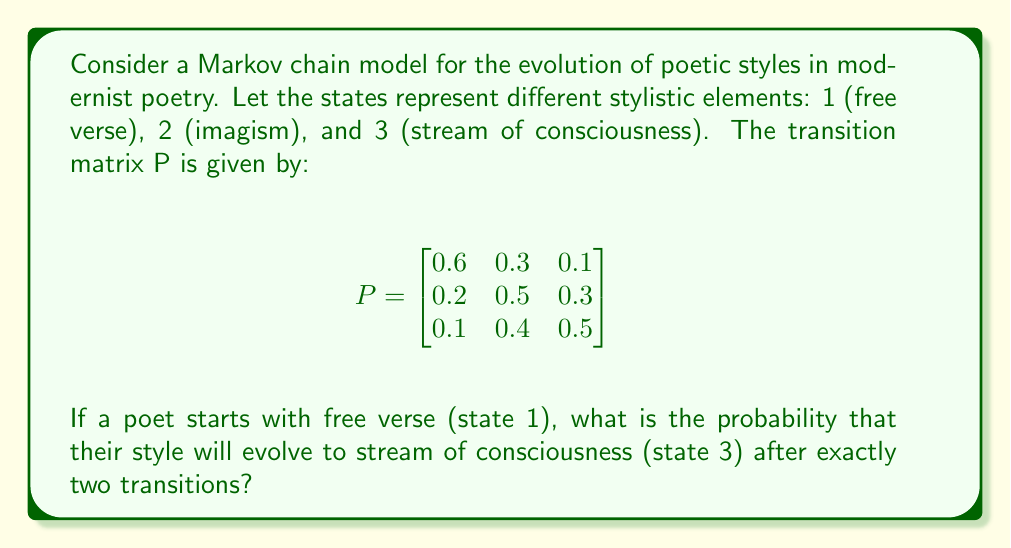Teach me how to tackle this problem. To solve this problem, we need to use the Chapman-Kolmogorov equations for Markov chains. We want to find the probability of going from state 1 to state 3 in exactly two steps.

Step 1: Calculate $P^2$ (the transition matrix for two steps)
$$P^2 = P \times P = \begin{bmatrix}
0.6 & 0.3 & 0.1 \\
0.2 & 0.5 & 0.3 \\
0.1 & 0.4 & 0.5
\end{bmatrix} \times \begin{bmatrix}
0.6 & 0.3 & 0.1 \\
0.2 & 0.5 & 0.3 \\
0.1 & 0.4 & 0.5
\end{bmatrix}$$

Step 2: Perform matrix multiplication
$$P^2 = \begin{bmatrix}
0.42 & 0.39 & 0.19 \\
0.23 & 0.46 & 0.31 \\
0.19 & 0.43 & 0.38
\end{bmatrix}$$

Step 3: Identify the required probability
The probability of going from state 1 to state 3 in two steps is given by the element in the first row, third column of $P^2$, which is 0.19.
Answer: 0.19 